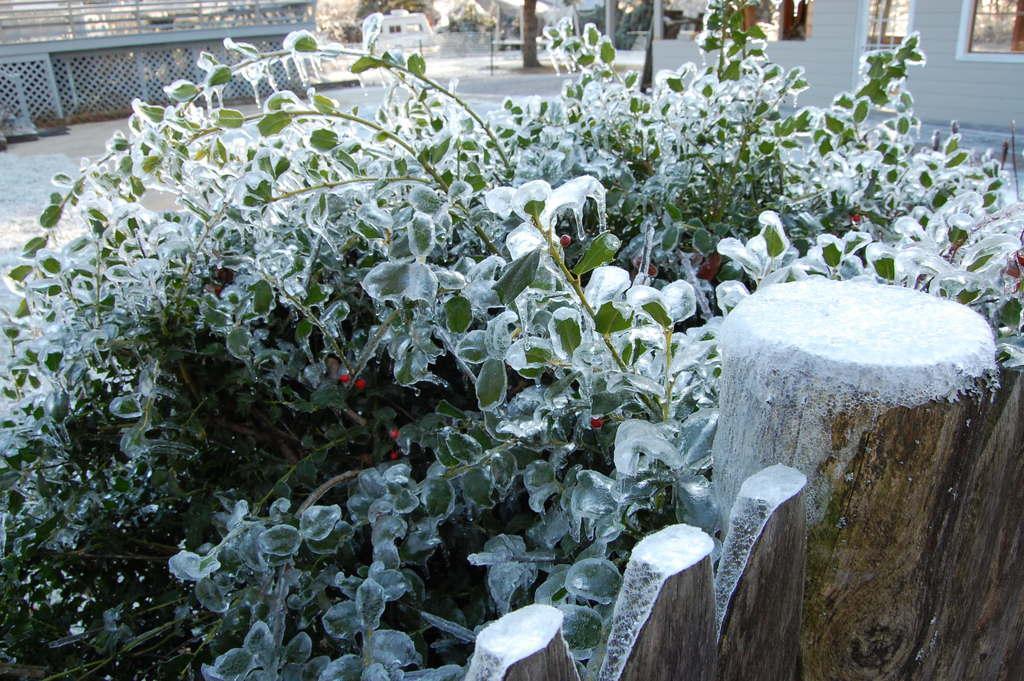Describe this image in one or two sentences. In this image I can see a huge wooden log and few plants. I can see ice on the plants. In the background I can see the building, the railing and few trees. 